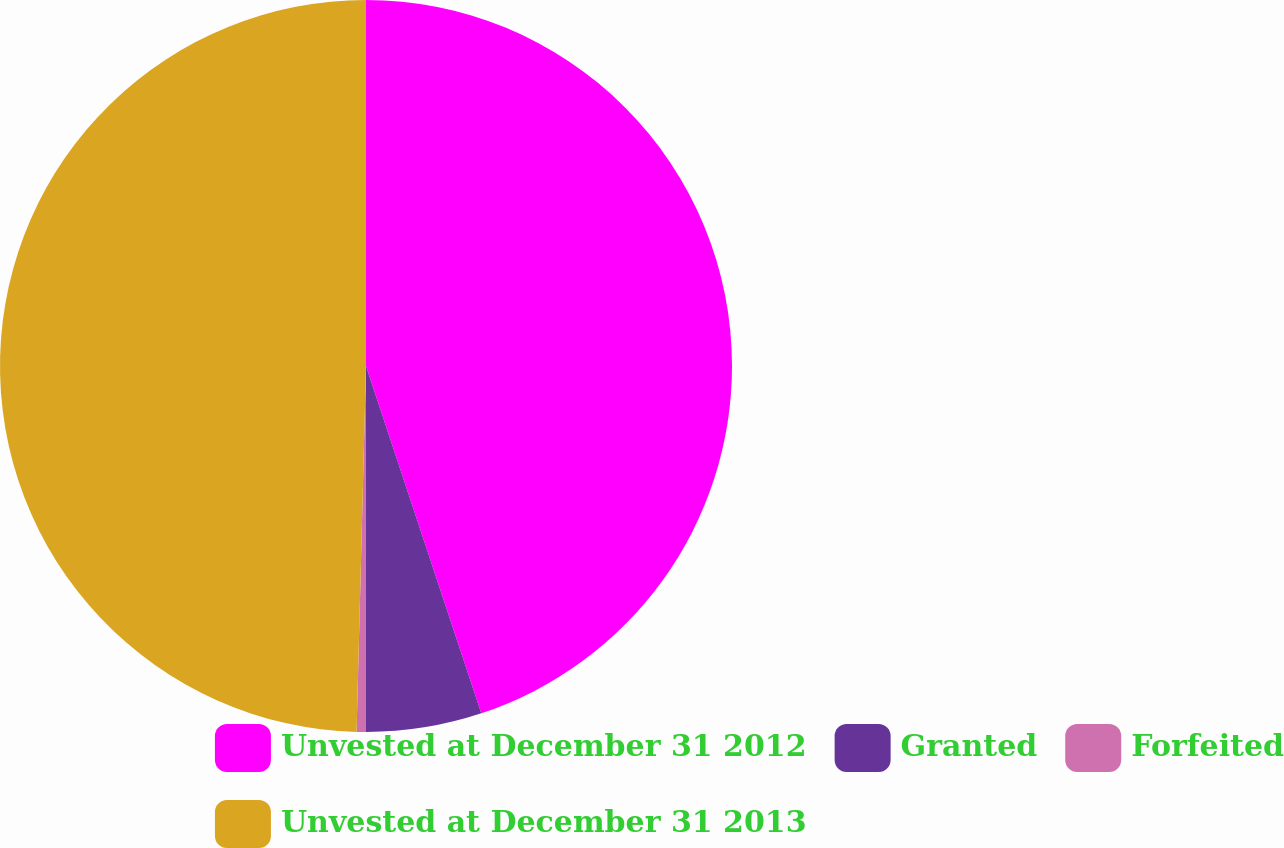<chart> <loc_0><loc_0><loc_500><loc_500><pie_chart><fcel>Unvested at December 31 2012<fcel>Granted<fcel>Forfeited<fcel>Unvested at December 31 2013<nl><fcel>44.9%<fcel>5.1%<fcel>0.41%<fcel>49.59%<nl></chart> 